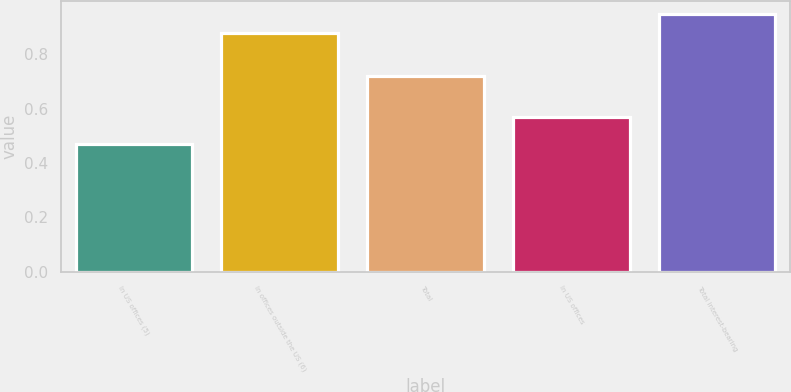Convert chart to OTSL. <chart><loc_0><loc_0><loc_500><loc_500><bar_chart><fcel>In US offices (5)<fcel>In offices outside the US (6)<fcel>Total<fcel>In US offices<fcel>Total interest-bearing<nl><fcel>0.47<fcel>0.88<fcel>0.72<fcel>0.57<fcel>0.95<nl></chart> 